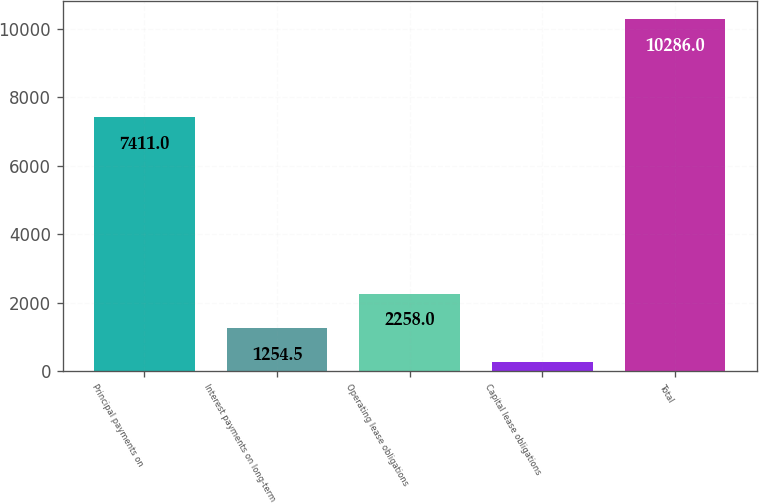<chart> <loc_0><loc_0><loc_500><loc_500><bar_chart><fcel>Principal payments on<fcel>Interest payments on long-term<fcel>Operating lease obligations<fcel>Capital lease obligations<fcel>Total<nl><fcel>7411<fcel>1254.5<fcel>2258<fcel>251<fcel>10286<nl></chart> 